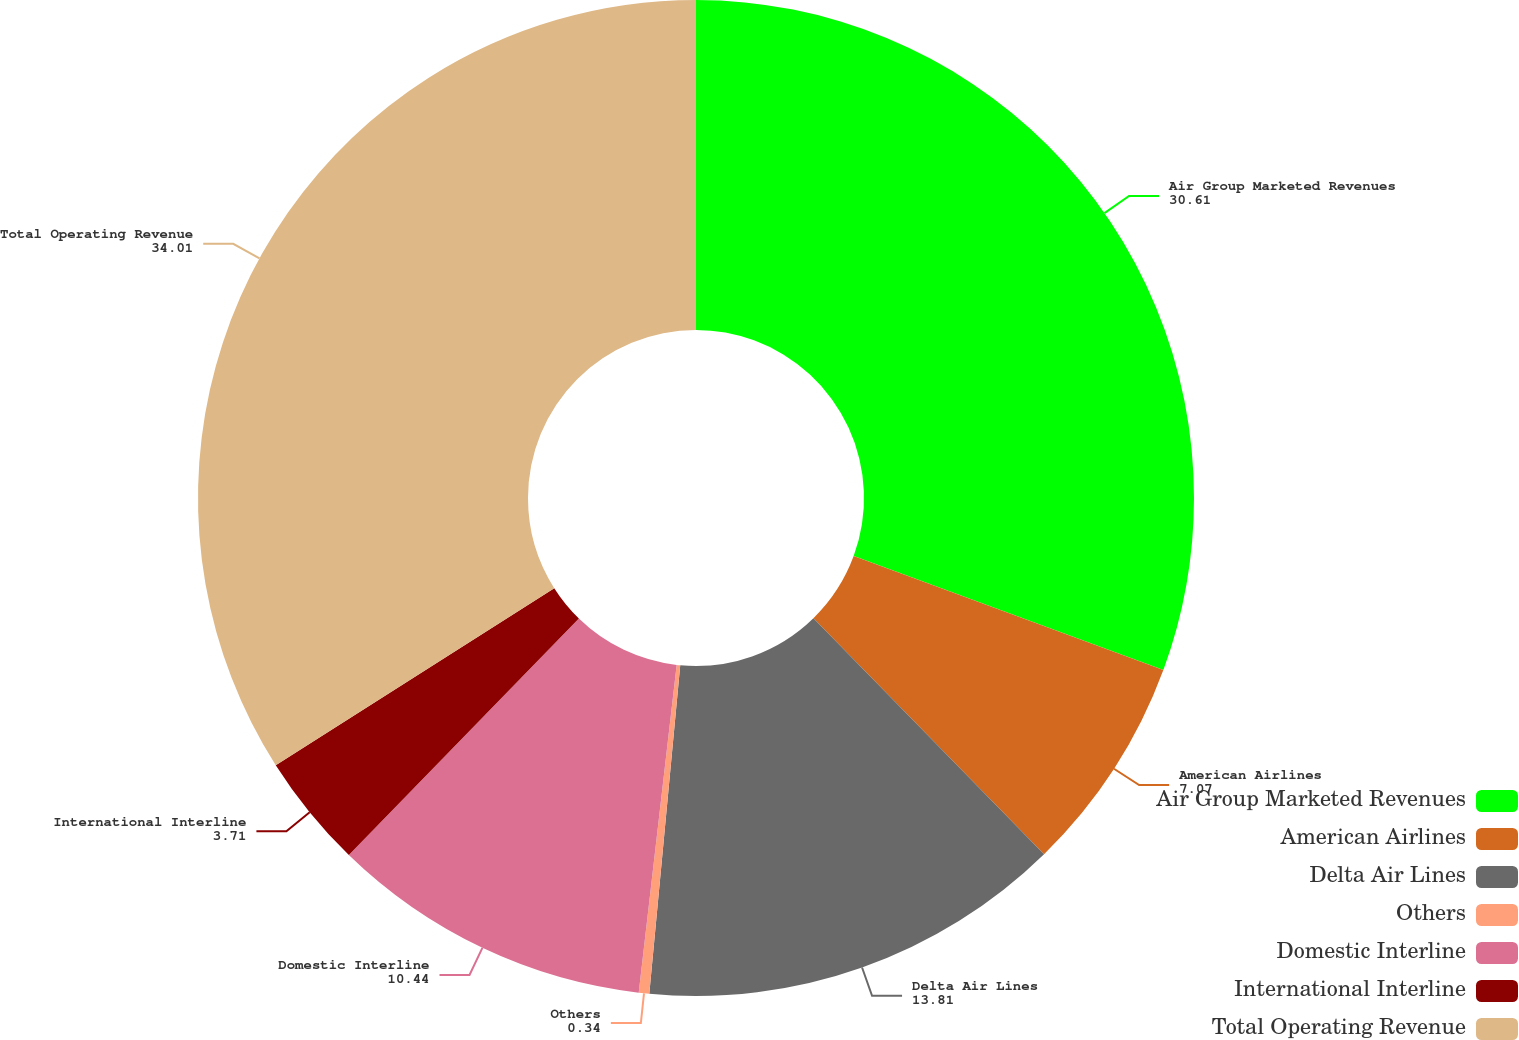<chart> <loc_0><loc_0><loc_500><loc_500><pie_chart><fcel>Air Group Marketed Revenues<fcel>American Airlines<fcel>Delta Air Lines<fcel>Others<fcel>Domestic Interline<fcel>International Interline<fcel>Total Operating Revenue<nl><fcel>30.61%<fcel>7.07%<fcel>13.81%<fcel>0.34%<fcel>10.44%<fcel>3.71%<fcel>34.01%<nl></chart> 